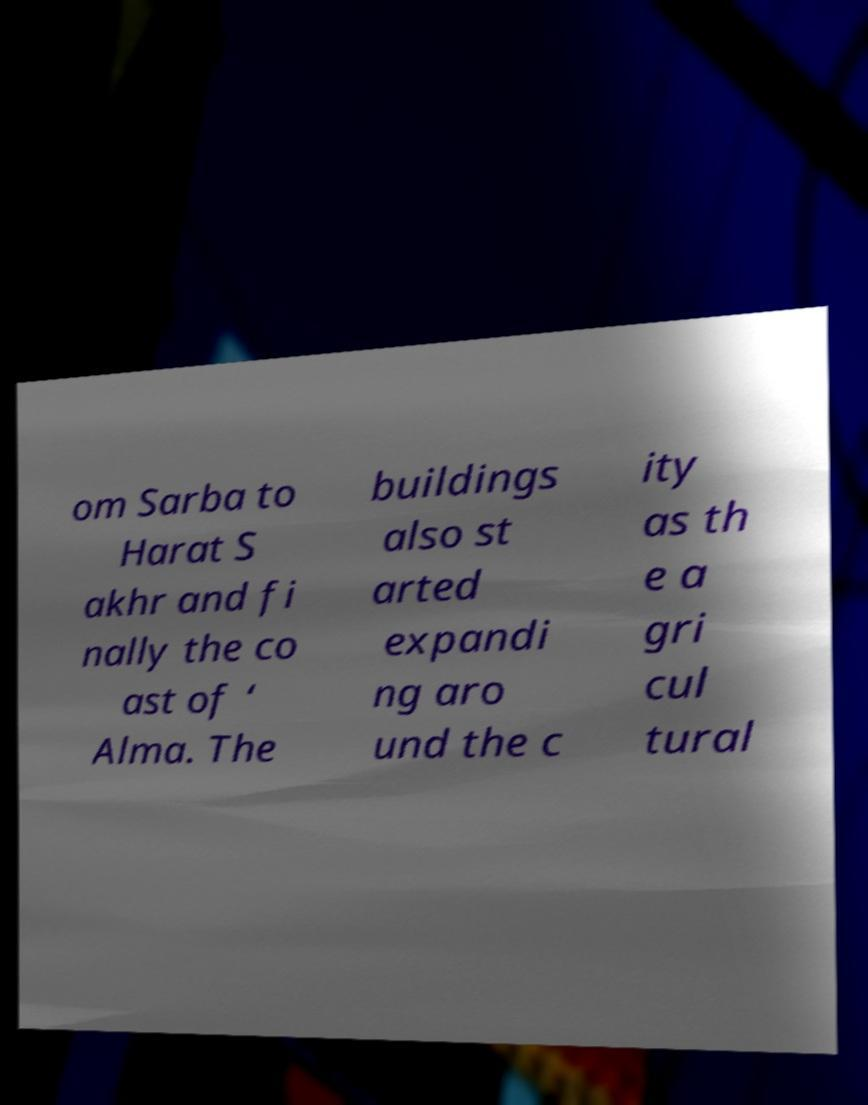For documentation purposes, I need the text within this image transcribed. Could you provide that? om Sarba to Harat S akhr and fi nally the co ast of ‘ Alma. The buildings also st arted expandi ng aro und the c ity as th e a gri cul tural 